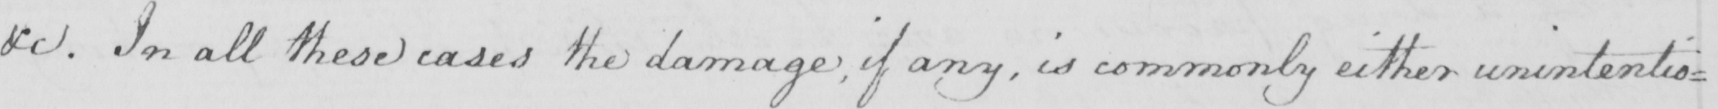Can you read and transcribe this handwriting? &c. In all these cases the damage, if any, is commonly either unintentio= 